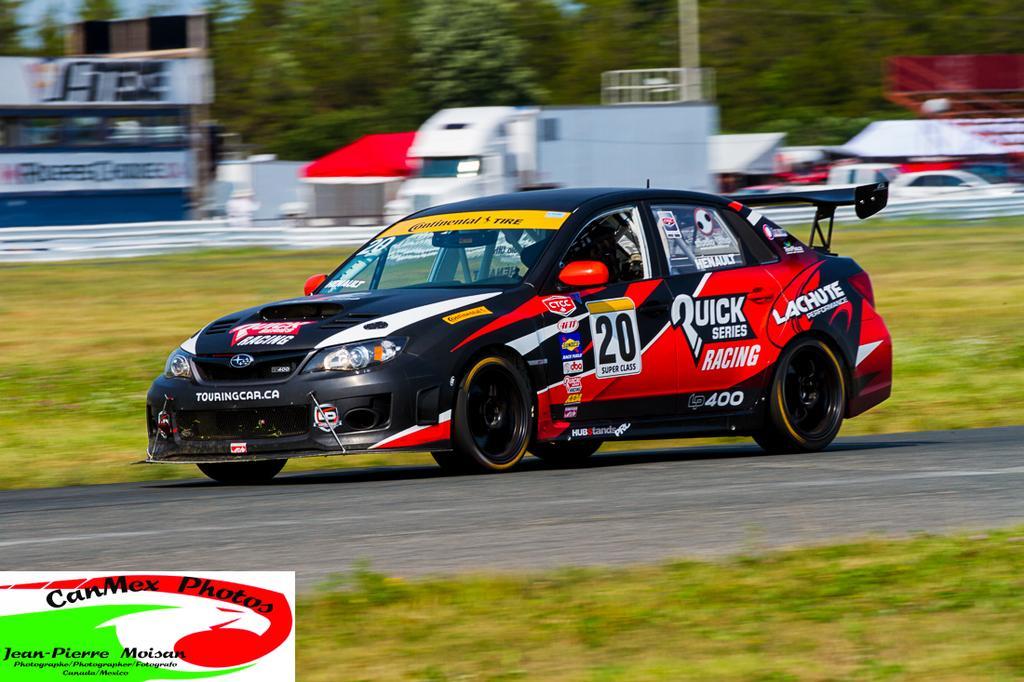Please provide a concise description of this image. In this image there are trees truncated towards the top of the image, there is an object truncated towards the left of the image, there are boards, there is text on the boards, there are objects truncated towards the right of the image, there is the road, there are vehicles on the road, there is grass, there is grass truncated towards the bottom of the image, there is text towards the bottom of the image. 